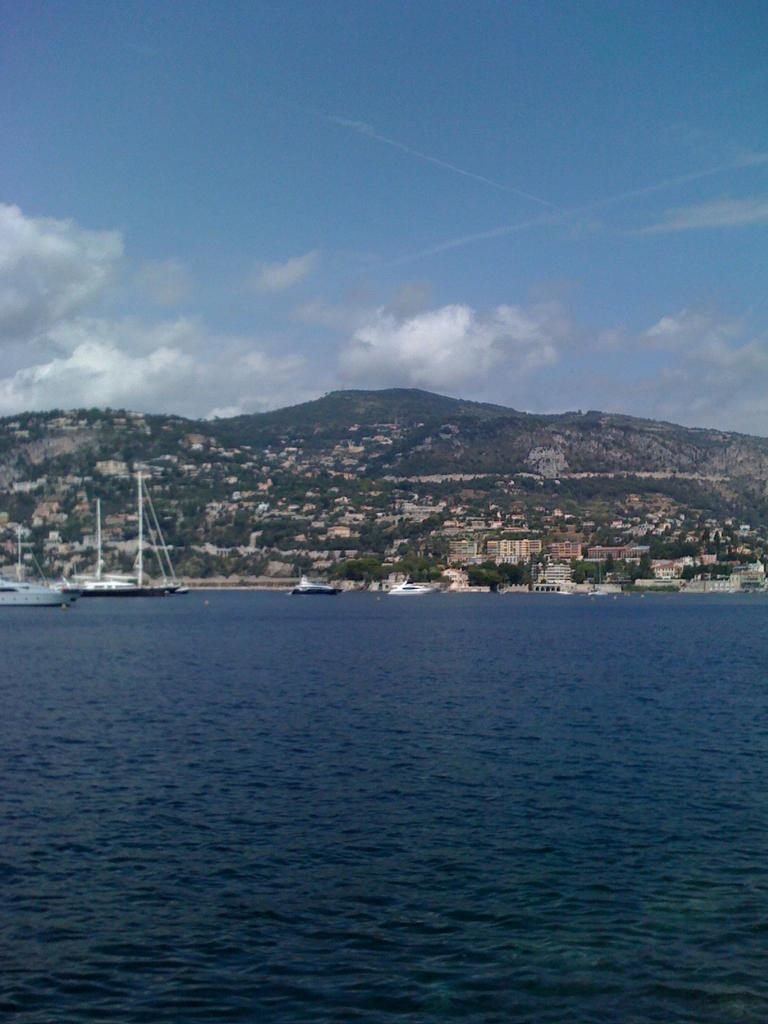What type of vehicles can be seen in the image? There are ships in the image. What structures are present in the image? There are buildings in the image. What type of natural vegetation is visible in the image? There are trees in the image. What type of geographical feature is visible in the image? There are mountains in the image. What part of the natural environment is visible at the top of the image? The sky is visible at the top of the image. What part of the natural environment is visible at the bottom of the image? Water is visible at the bottom of the image. What brand of toothpaste is being advertised on the side of the ship in the image? There is no toothpaste or advertisement present on the side of the ship in the image. What type of trouble are the ships facing in the image? There is no indication of trouble or any issues with the ships in the image. 